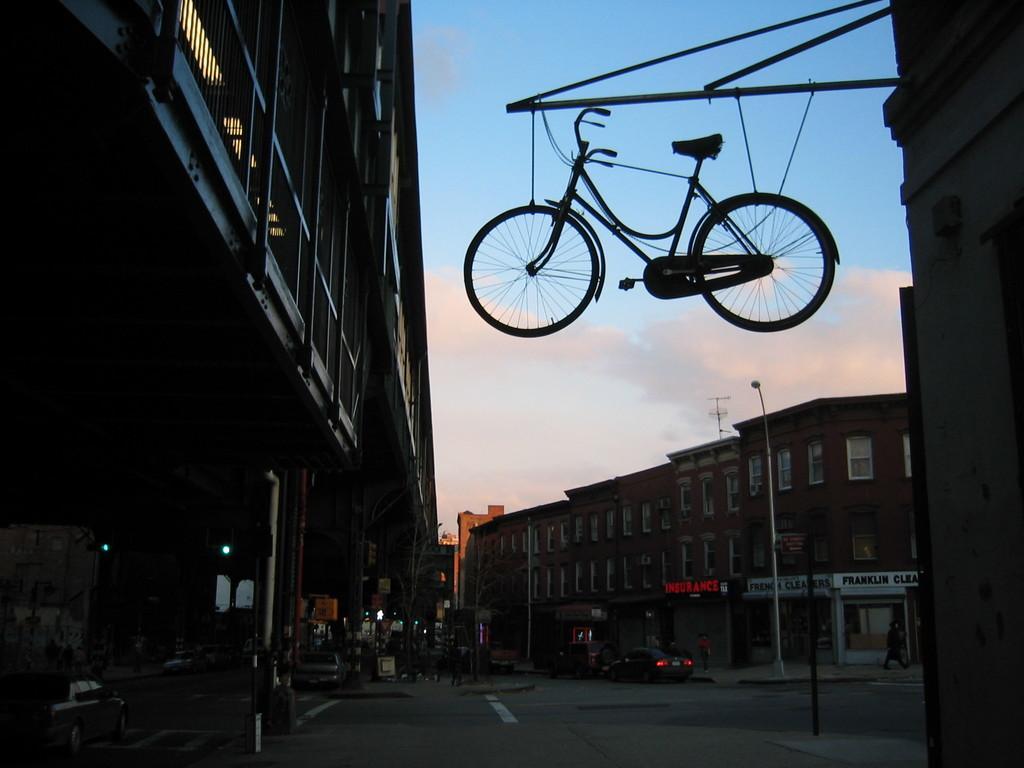How would you summarize this image in a sentence or two? In this picture we can see few buildings, poles, lights, vehicles and group of people, and also we can see a bicycle in the air and it is tied with cables to the metal rod. 